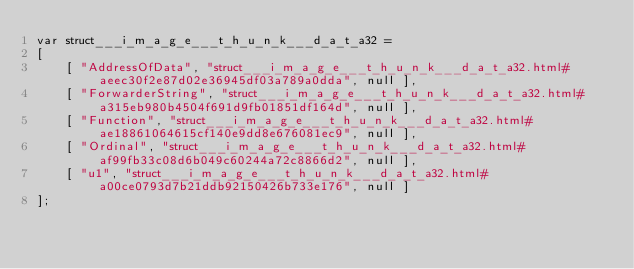Convert code to text. <code><loc_0><loc_0><loc_500><loc_500><_JavaScript_>var struct___i_m_a_g_e___t_h_u_n_k___d_a_t_a32 =
[
    [ "AddressOfData", "struct___i_m_a_g_e___t_h_u_n_k___d_a_t_a32.html#aeec30f2e87d02e36945df03a789a0dda", null ],
    [ "ForwarderString", "struct___i_m_a_g_e___t_h_u_n_k___d_a_t_a32.html#a315eb980b4504f691d9fb01851df164d", null ],
    [ "Function", "struct___i_m_a_g_e___t_h_u_n_k___d_a_t_a32.html#ae18861064615cf140e9dd8e676081ec9", null ],
    [ "Ordinal", "struct___i_m_a_g_e___t_h_u_n_k___d_a_t_a32.html#af99fb33c08d6b049c60244a72c8866d2", null ],
    [ "u1", "struct___i_m_a_g_e___t_h_u_n_k___d_a_t_a32.html#a00ce0793d7b21ddb92150426b733e176", null ]
];</code> 